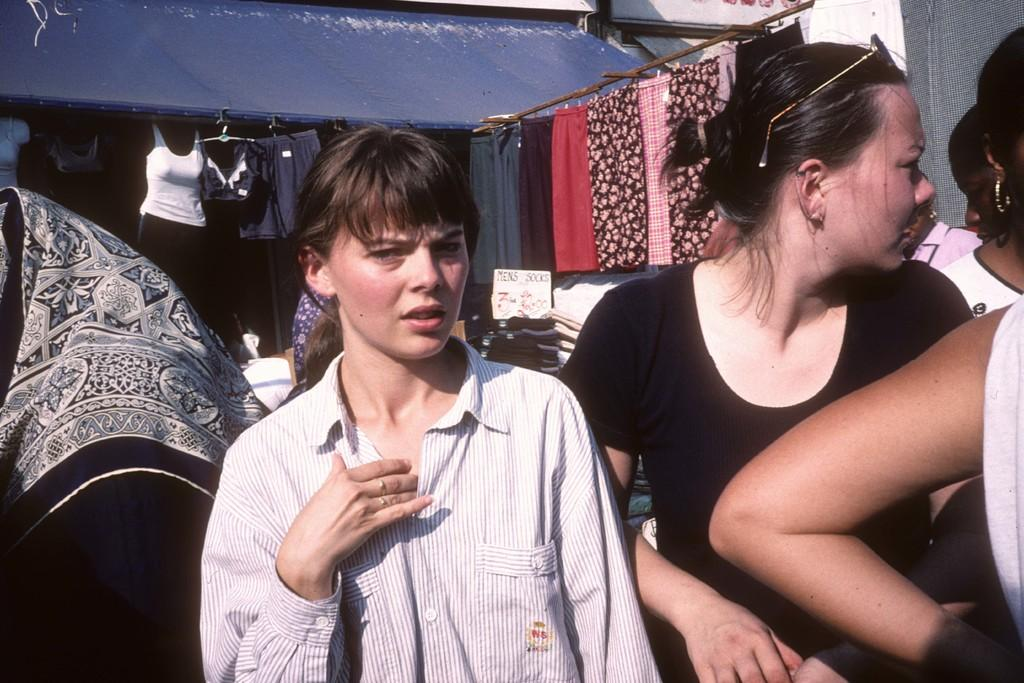What is happening in the image? There are people standing in the image. What can be seen in the background of the image? There are clothes and a roof visible in the background of the image. What type of rice is being served at the seashore in the image? There is no seashore or rice present in the image. Is there a secretary working in the background of the image? There is no secretary present in the image. 